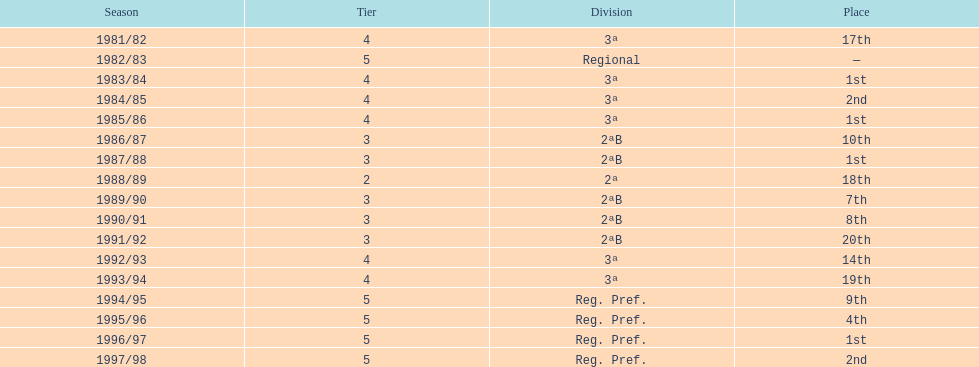In which year is there no location specified? 1982/83. 